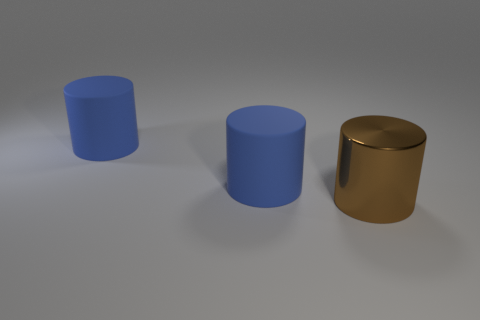What number of other objects are the same size as the brown cylinder?
Provide a succinct answer. 2. How many brown objects are matte things or metallic cylinders?
Provide a short and direct response. 1. What number of large blue cylinders are the same material as the big brown cylinder?
Your answer should be very brief. 0. There is a brown metal object; are there any big shiny cylinders behind it?
Provide a short and direct response. No. Is there a big blue rubber object of the same shape as the brown metal object?
Offer a very short reply. Yes. Is there a brown cylinder that has the same size as the brown object?
Give a very brief answer. No. What is the material of the brown object?
Offer a terse response. Metal. What number of other objects are there of the same color as the shiny cylinder?
Your answer should be very brief. 0. How many big blue rubber cylinders are there?
Your answer should be very brief. 2. What number of objects are either blue rubber cubes or cylinders on the left side of the metal object?
Give a very brief answer. 2. 